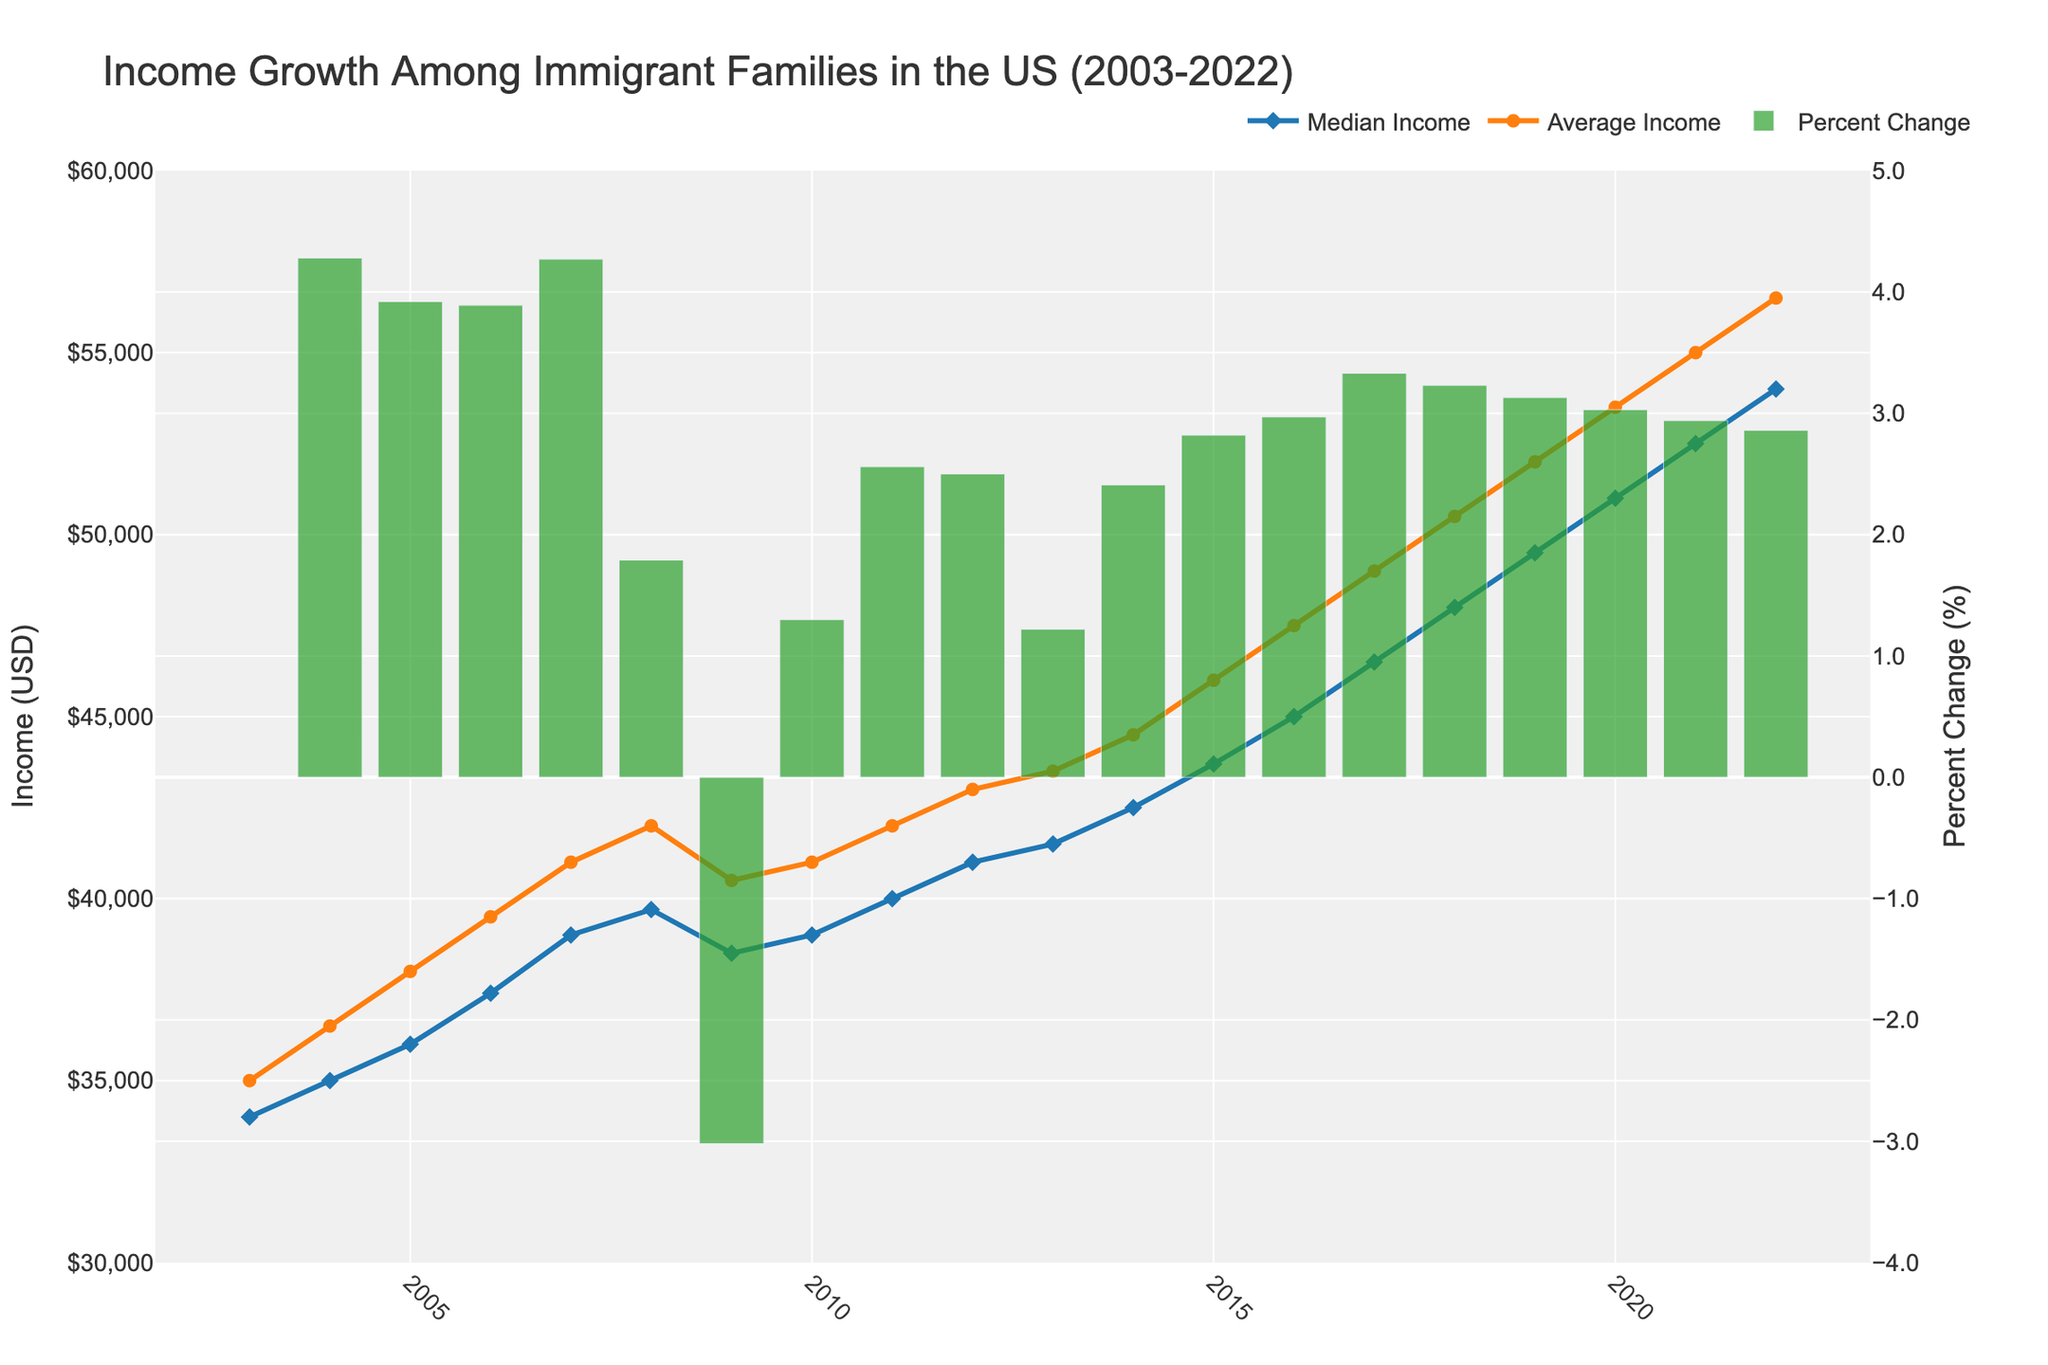What's the title of the plot? The title of the plot can be found at the top of the figure. It is usually descriptive and summarizes what the plot is about.
Answer: Income Growth Among Immigrant Families in the US (2003-2022) What are the two types of income trends shown in the plot? The two types of income trends are represented by distinct line styles and marker shapes, as indicated in the legend.
Answer: Median Income and Average Income What is the color used for the Median Income line? The Median Income line is blue, as indicated by its consistent appearance in the figure and the corresponding legend entry.
Answer: Blue In which year did the Percent Change drop the most? Percent Change is represented as bars in green. The bar that dips the most is easily identifiable by visual inspection.
Answer: 2009 What was the Median Income in 2010? The value of Median Income for 2010 can be found by locating the corresponding data point on the blue line.
Answer: 39,000 USD Which year shows the highest Average Income? By tracing the orange line to its highest point and then identifying the corresponding year on the x-axis, we find the answer.
Answer: 2022 How many times did Percent Change drop below 0 during the 20 years? By counting the number of green bars that fall below the zero line on the Percent Change axis, we get the answer.
Answer: 1 What's the percent change in 2015 compared to 2014? Look for the green bar for the year 2015 and refer to the value to determine the percent change from 2014.
Answer: 2.82% What is the difference in Average Income between 2003 and 2022? Subtract the Average Income of 2003 from that of 2022 by using the values from the orange line.
Answer: 21,500 USD Compare the Trend of Median Income and Percent Change in 2007. Did they both increase or decrease? By examining the relative positions of the blue line and green bar for the year 2007, we see that they both are above their respective previous values.
Answer: Increase 